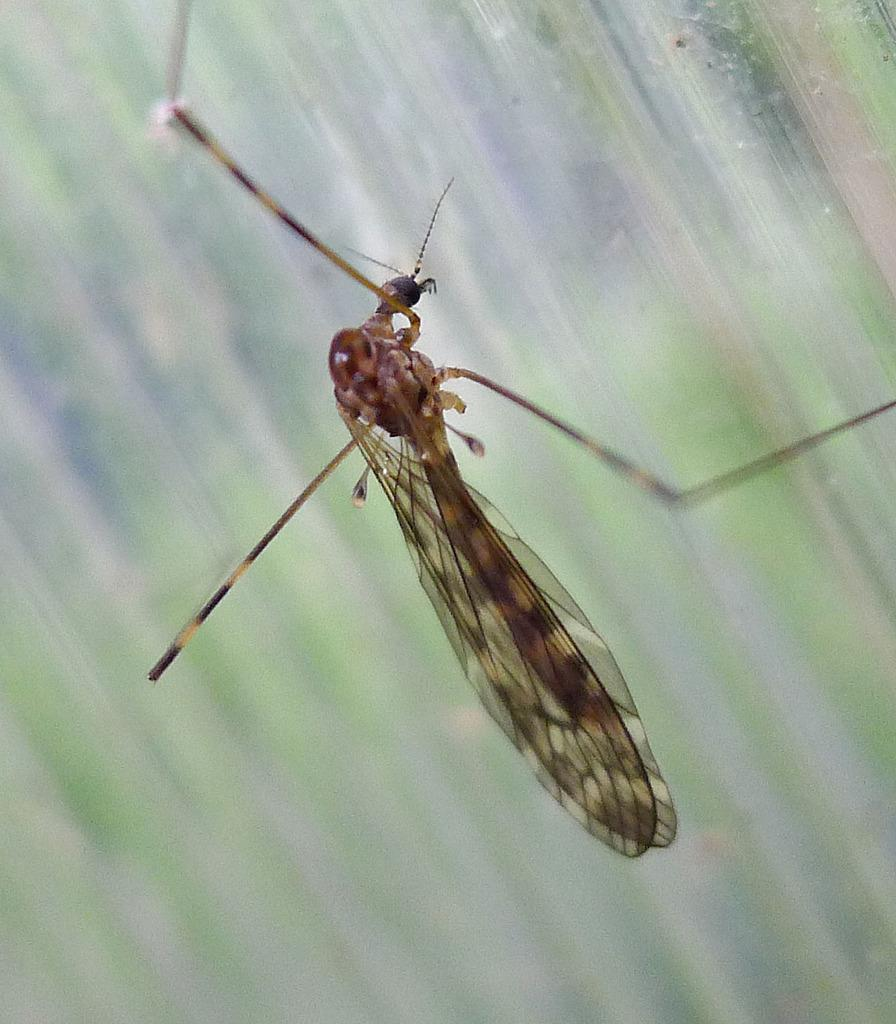What is the main subject of the image? The main subject of the image is a mosquito. Where is the mosquito located in the image? The mosquito is standing on the wall. What are the mosquito's hobbies in the image? There is no information about the mosquito's hobbies in the image. Mosquitoes do not have hobbies, as they are insects. 